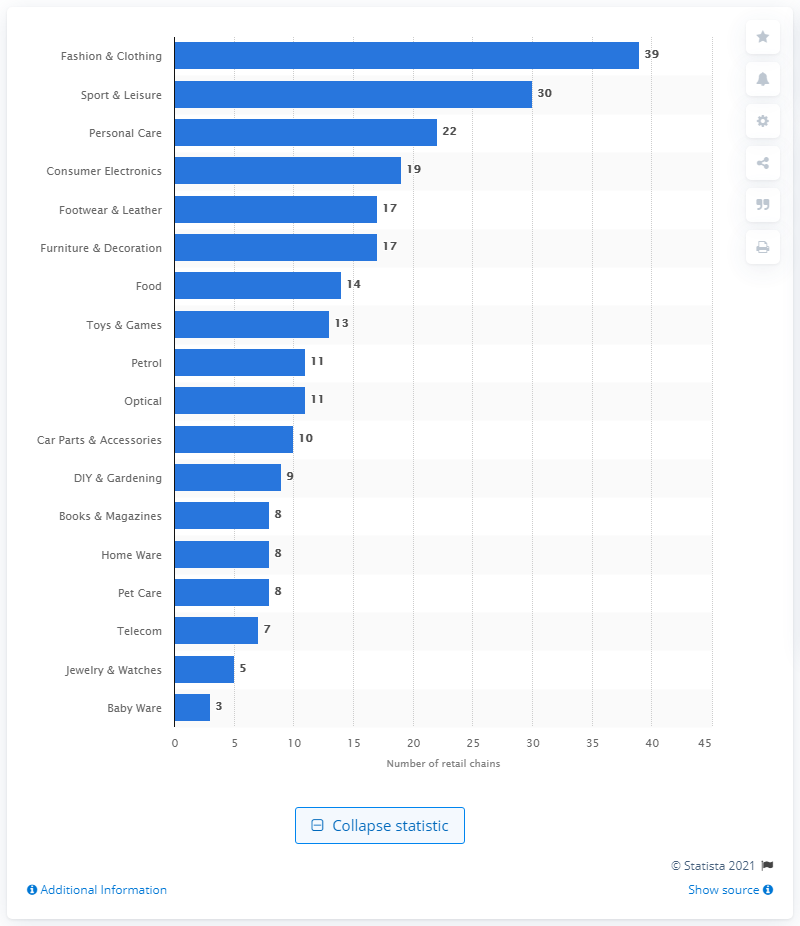List a handful of essential elements in this visual. In the year 2020, there were 22 retail chains in the personal care industry in the Czech Republic. 